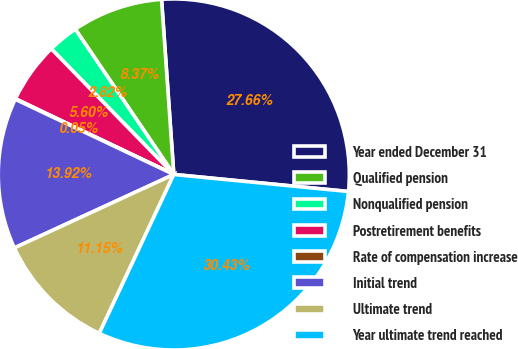Convert chart. <chart><loc_0><loc_0><loc_500><loc_500><pie_chart><fcel>Year ended December 31<fcel>Qualified pension<fcel>Nonqualified pension<fcel>Postretirement benefits<fcel>Rate of compensation increase<fcel>Initial trend<fcel>Ultimate trend<fcel>Year ultimate trend reached<nl><fcel>27.66%<fcel>8.37%<fcel>2.82%<fcel>5.6%<fcel>0.05%<fcel>13.92%<fcel>11.15%<fcel>30.43%<nl></chart> 